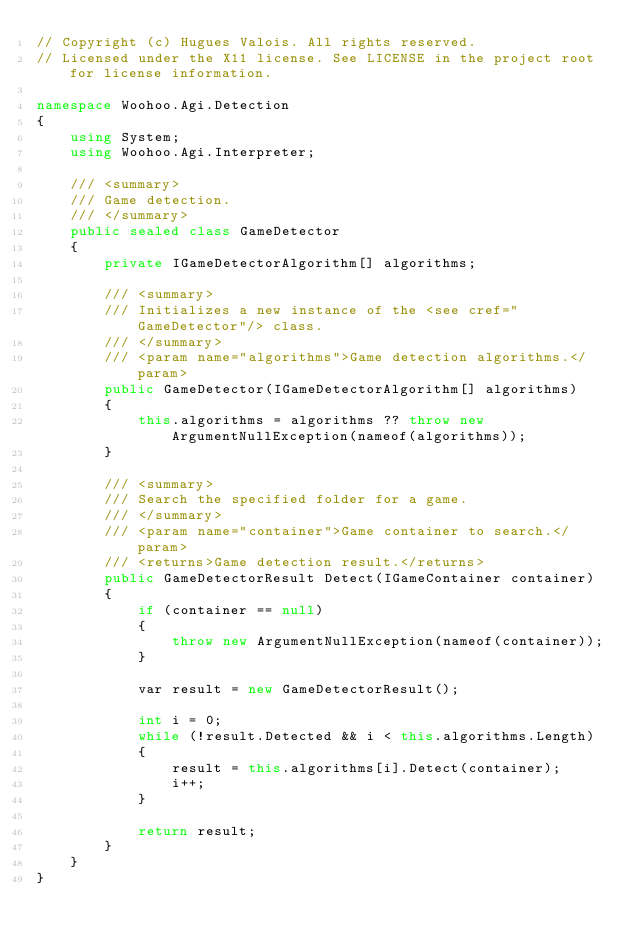<code> <loc_0><loc_0><loc_500><loc_500><_C#_>// Copyright (c) Hugues Valois. All rights reserved.
// Licensed under the X11 license. See LICENSE in the project root for license information.

namespace Woohoo.Agi.Detection
{
    using System;
    using Woohoo.Agi.Interpreter;

    /// <summary>
    /// Game detection.
    /// </summary>
    public sealed class GameDetector
    {
        private IGameDetectorAlgorithm[] algorithms;

        /// <summary>
        /// Initializes a new instance of the <see cref="GameDetector"/> class.
        /// </summary>
        /// <param name="algorithms">Game detection algorithms.</param>
        public GameDetector(IGameDetectorAlgorithm[] algorithms)
        {
            this.algorithms = algorithms ?? throw new ArgumentNullException(nameof(algorithms));
        }

        /// <summary>
        /// Search the specified folder for a game.
        /// </summary>
        /// <param name="container">Game container to search.</param>
        /// <returns>Game detection result.</returns>
        public GameDetectorResult Detect(IGameContainer container)
        {
            if (container == null)
            {
                throw new ArgumentNullException(nameof(container));
            }

            var result = new GameDetectorResult();

            int i = 0;
            while (!result.Detected && i < this.algorithms.Length)
            {
                result = this.algorithms[i].Detect(container);
                i++;
            }

            return result;
        }
    }
}
</code> 